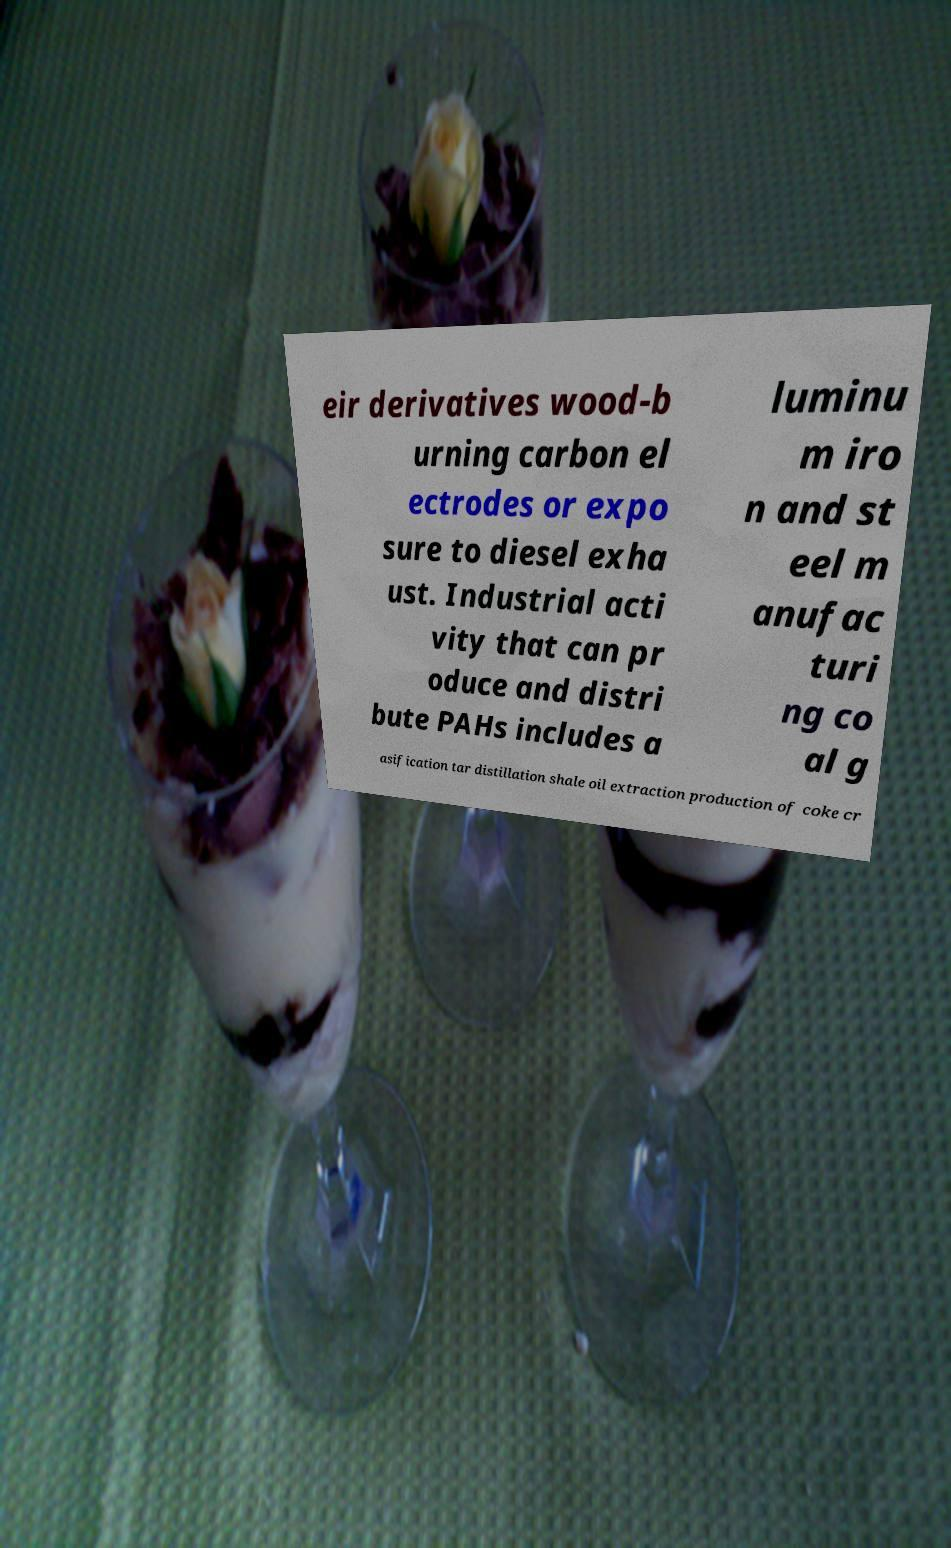Can you read and provide the text displayed in the image?This photo seems to have some interesting text. Can you extract and type it out for me? eir derivatives wood-b urning carbon el ectrodes or expo sure to diesel exha ust. Industrial acti vity that can pr oduce and distri bute PAHs includes a luminu m iro n and st eel m anufac turi ng co al g asification tar distillation shale oil extraction production of coke cr 